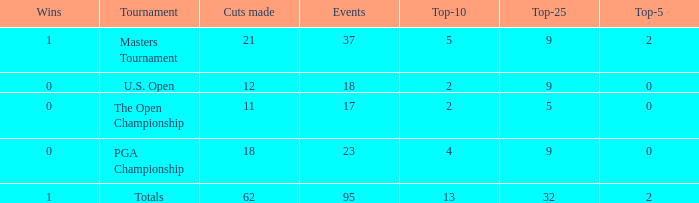What is the number of wins that is in the top 10 and larger than 13? None. 